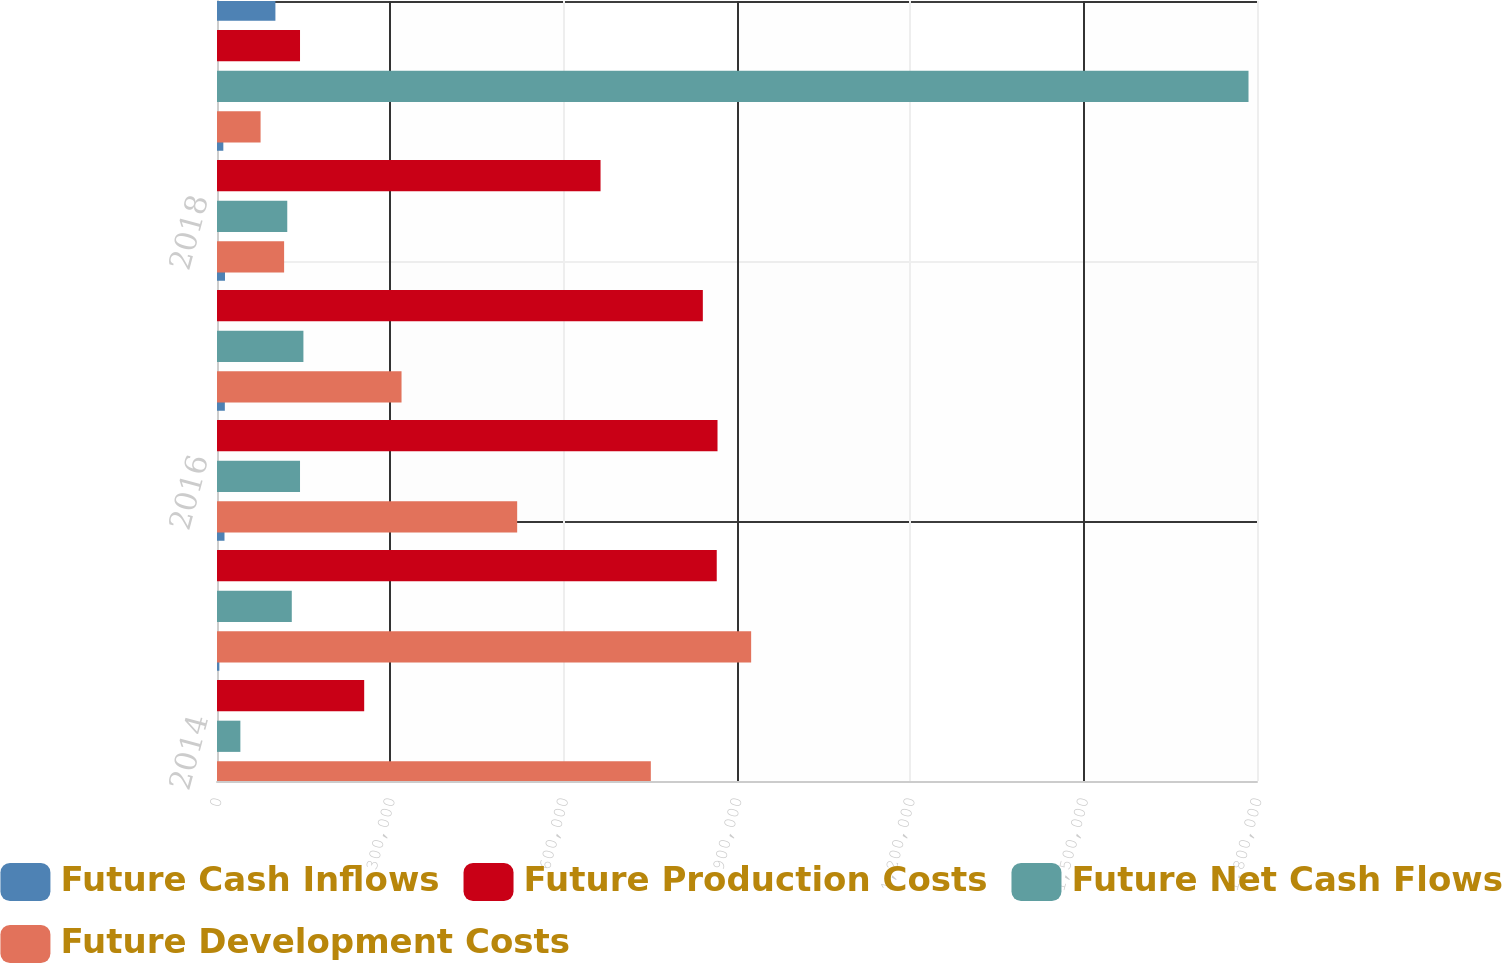Convert chart. <chart><loc_0><loc_0><loc_500><loc_500><stacked_bar_chart><ecel><fcel>2014<fcel>2015<fcel>2016<fcel>2017<fcel>2018<fcel>Thereafter (b)<nl><fcel>Future Cash Inflows<fcel>4076<fcel>12974<fcel>13569<fcel>13831<fcel>10956<fcel>101101<nl><fcel>Future Production Costs<fcel>254760<fcel>864940<fcel>866283<fcel>840869<fcel>663828<fcel>143693<nl><fcel>Future Net Cash Flows<fcel>40458<fcel>129438<fcel>143693<fcel>149559<fcel>121608<fcel>1.78531e+06<nl><fcel>Future Development Costs<fcel>750851<fcel>924482<fcel>519534<fcel>319391<fcel>116153<fcel>75427<nl></chart> 